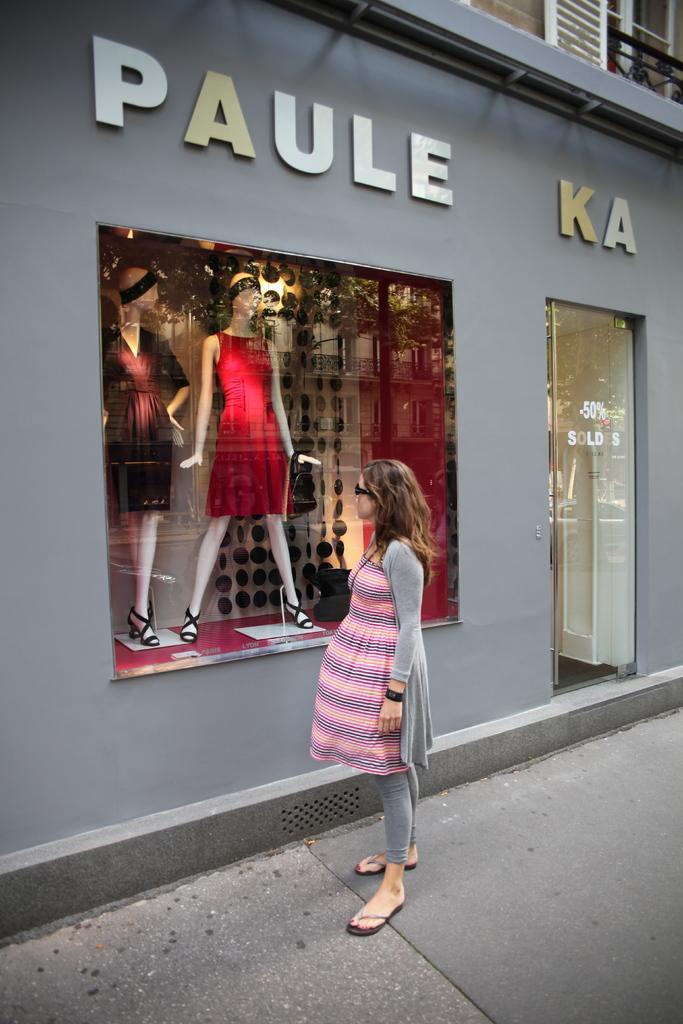Could you give a brief overview of what you see in this image? In this image, I can see a woman standing on a pathway. In front of the woman, there is a shop with a name board, a glass door and I can see the mannequins through a glass window. 